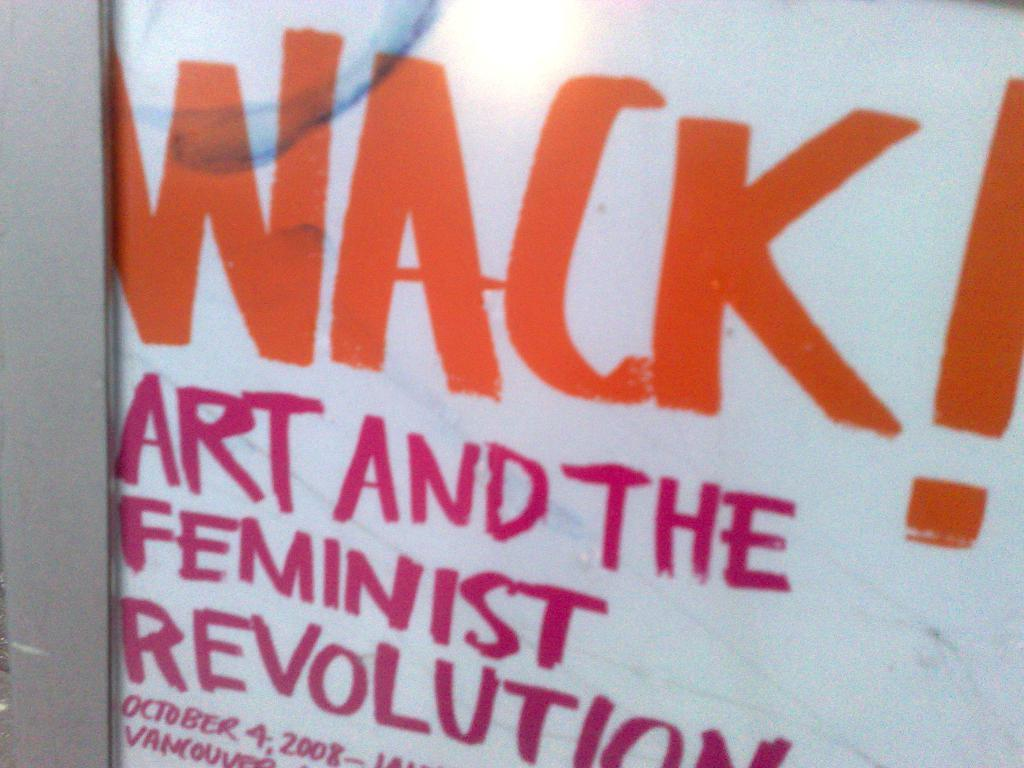<image>
Render a clear and concise summary of the photo. a white image with the word wack on it 